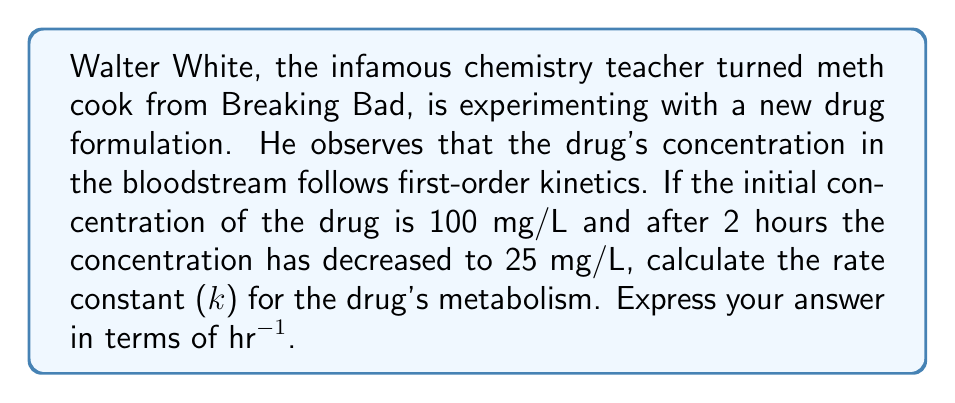Can you solve this math problem? To solve this problem, we'll use the first-order kinetics equation and the given information:

1) The first-order kinetics equation is:

   $$C(t) = C_0e^{-kt}$$

   Where:
   $C(t)$ is the concentration at time $t$
   $C_0$ is the initial concentration
   $k$ is the rate constant
   $t$ is time

2) We know:
   $C_0 = 100$ mg/L
   $C(2) = 25$ mg/L (concentration after 2 hours)
   $t = 2$ hours

3) Let's substitute these values into the equation:

   $$25 = 100e^{-k(2)}$$

4) Divide both sides by 100:

   $$0.25 = e^{-2k}$$

5) Take the natural log of both sides:

   $$\ln(0.25) = -2k$$

6) Solve for $k$:

   $$k = -\frac{\ln(0.25)}{2}$$

7) Calculate the value:

   $$k = -\frac{-1.3862943611}{2} = 0.6931471806 \text{ hr}^{-1}$$

This rate constant indicates how quickly the drug is being metabolized in the body, which is crucial information for Walter White's drug empire in Breaking Bad.
Answer: $k \approx 0.69 \text{ hr}^{-1}$ 